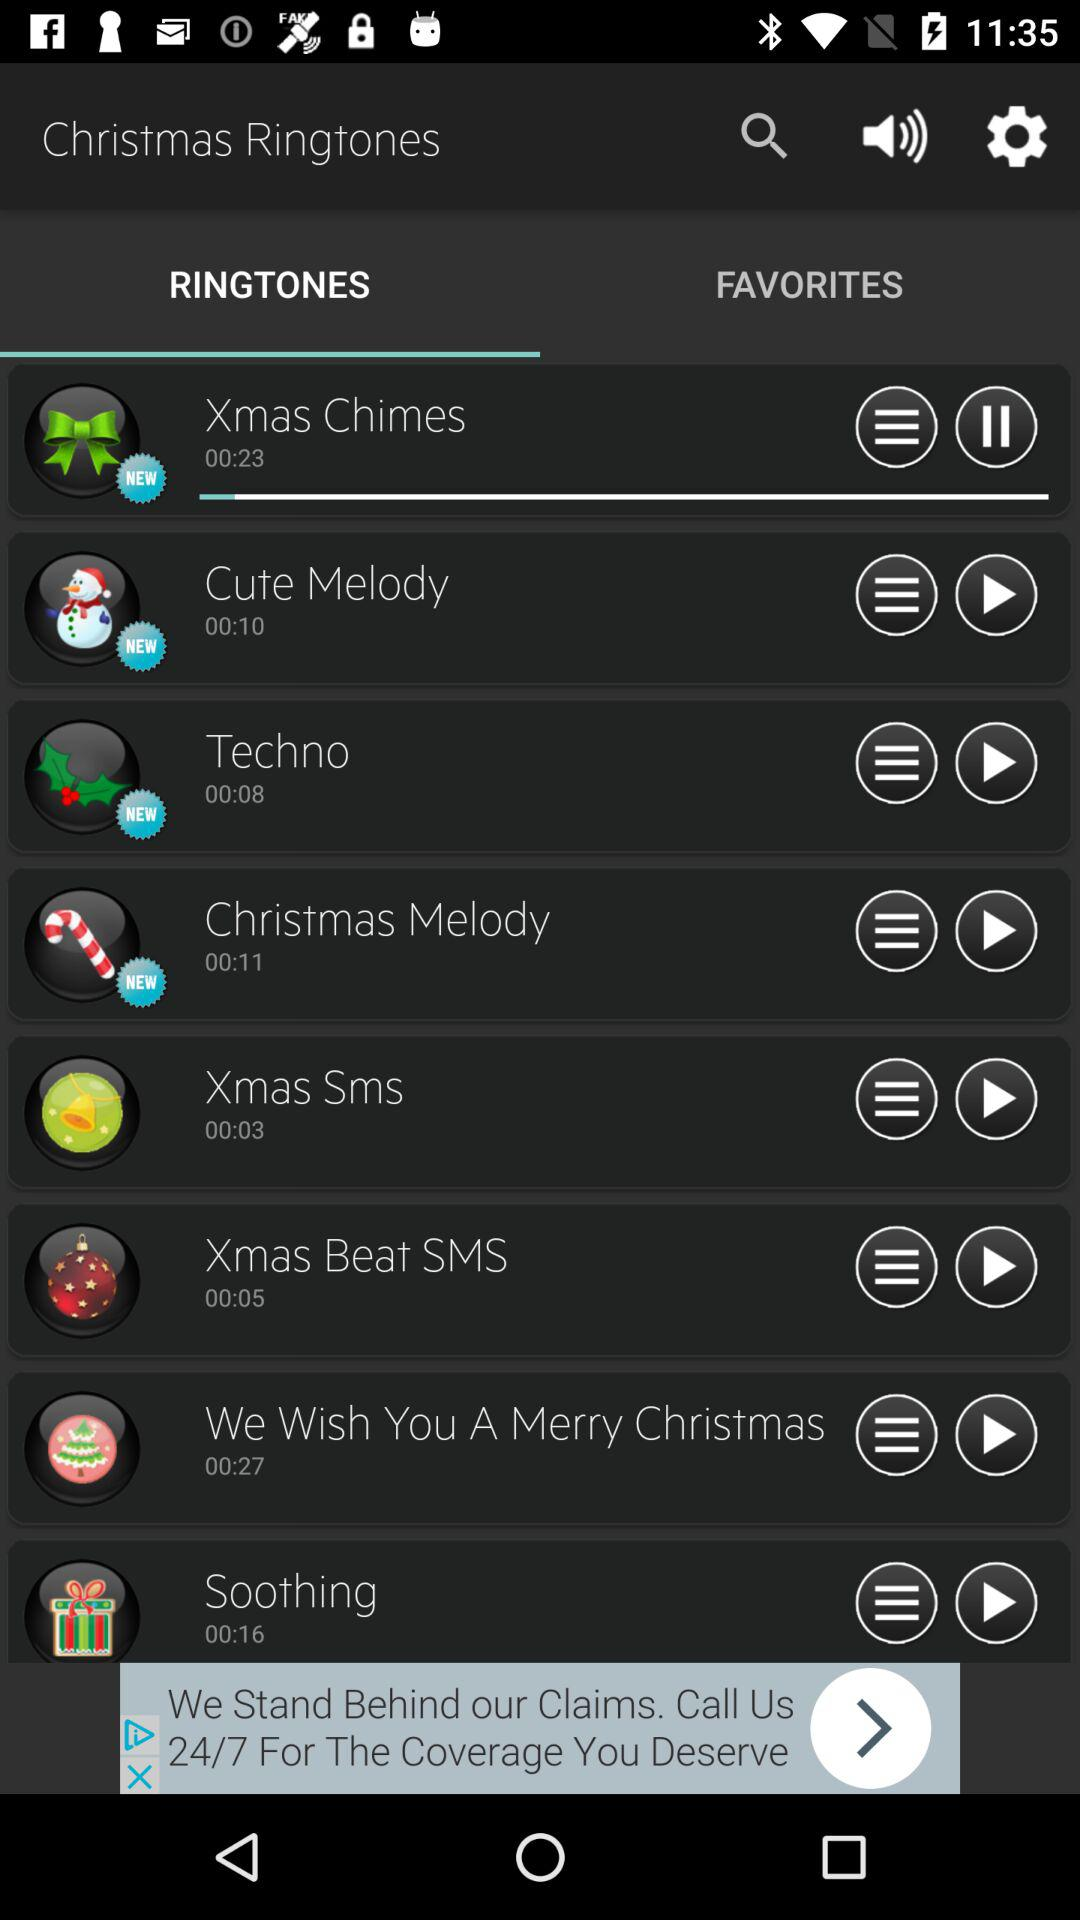How long is the "Cute Melody" ringtone? The "Cute Melody" ringtone is 10 seconds long. 